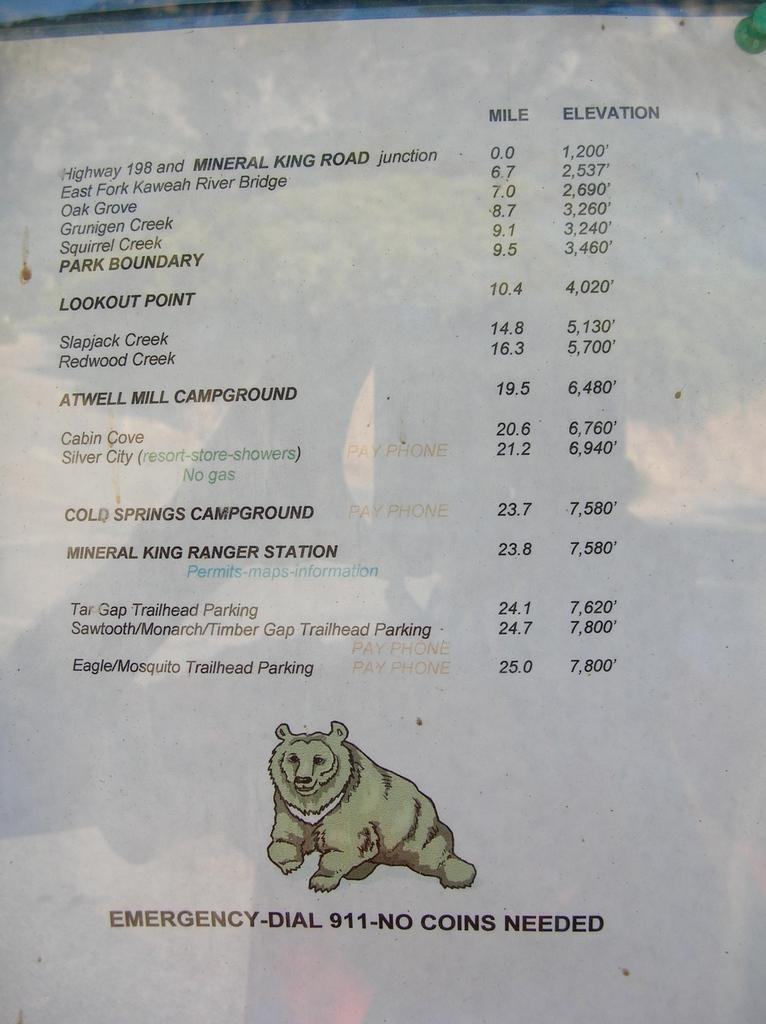What type of content is present on the paper in the image? There are words and numbers on the paper. Is there any visual element on the paper? Yes, there is a photo of a bear on the paper. What type of toothpaste is being advertised in the image? There is no toothpaste present in the image; it features a paper with words, numbers, and a photo of a bear. How does the light affect the visibility of the words and numbers on the paper? The provided facts do not mention any light source or its effect on the visibility of the words and numbers on the paper. 